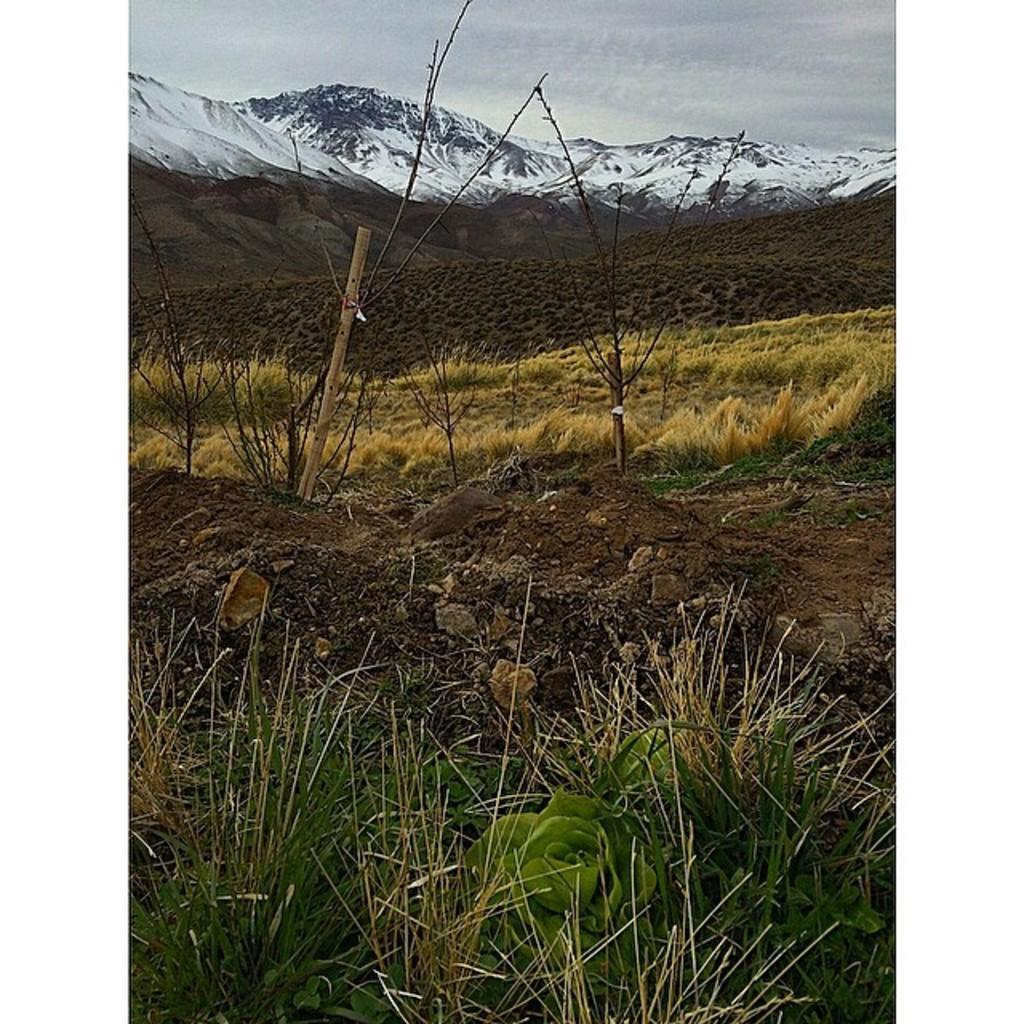What type of vegetation can be seen in the image? There is grass and plants in the image. What geographical features are present in the image? There are hills and mountains in the image. What can be seen in the background of the image? The sky is visible in the background of the image. What type of fuel is being used by the bears in the image? There are no bears present in the image, so there is no fuel being used by them. What is the range of the mountains in the image? The image does not provide information about the range of the mountains, only that they are visible. 